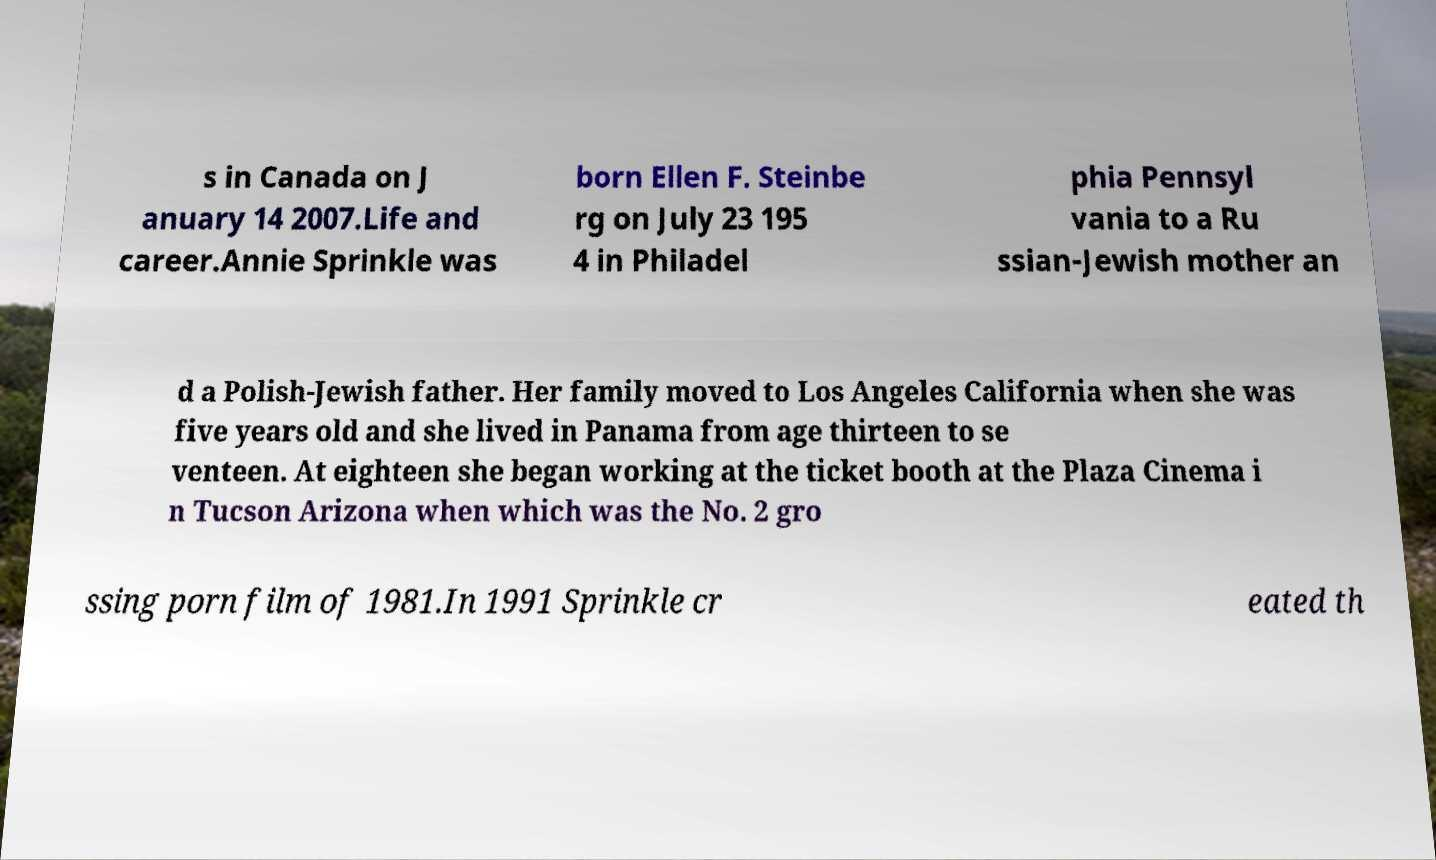Please identify and transcribe the text found in this image. s in Canada on J anuary 14 2007.Life and career.Annie Sprinkle was born Ellen F. Steinbe rg on July 23 195 4 in Philadel phia Pennsyl vania to a Ru ssian-Jewish mother an d a Polish-Jewish father. Her family moved to Los Angeles California when she was five years old and she lived in Panama from age thirteen to se venteen. At eighteen she began working at the ticket booth at the Plaza Cinema i n Tucson Arizona when which was the No. 2 gro ssing porn film of 1981.In 1991 Sprinkle cr eated th 